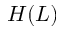Convert formula to latex. <formula><loc_0><loc_0><loc_500><loc_500>H ( L )</formula> 